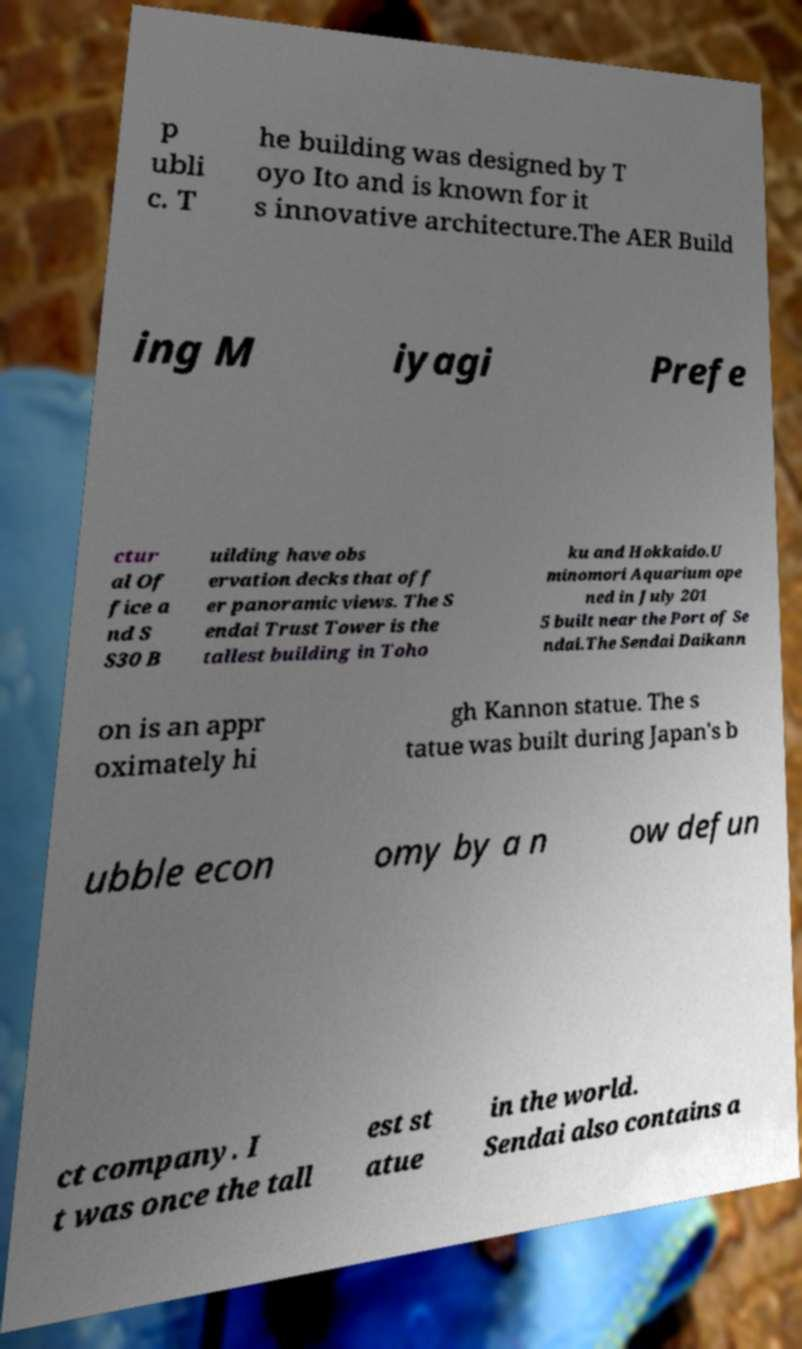Could you extract and type out the text from this image? p ubli c. T he building was designed by T oyo Ito and is known for it s innovative architecture.The AER Build ing M iyagi Prefe ctur al Of fice a nd S S30 B uilding have obs ervation decks that off er panoramic views. The S endai Trust Tower is the tallest building in Toho ku and Hokkaido.U minomori Aquarium ope ned in July 201 5 built near the Port of Se ndai.The Sendai Daikann on is an appr oximately hi gh Kannon statue. The s tatue was built during Japan's b ubble econ omy by a n ow defun ct company. I t was once the tall est st atue in the world. Sendai also contains a 